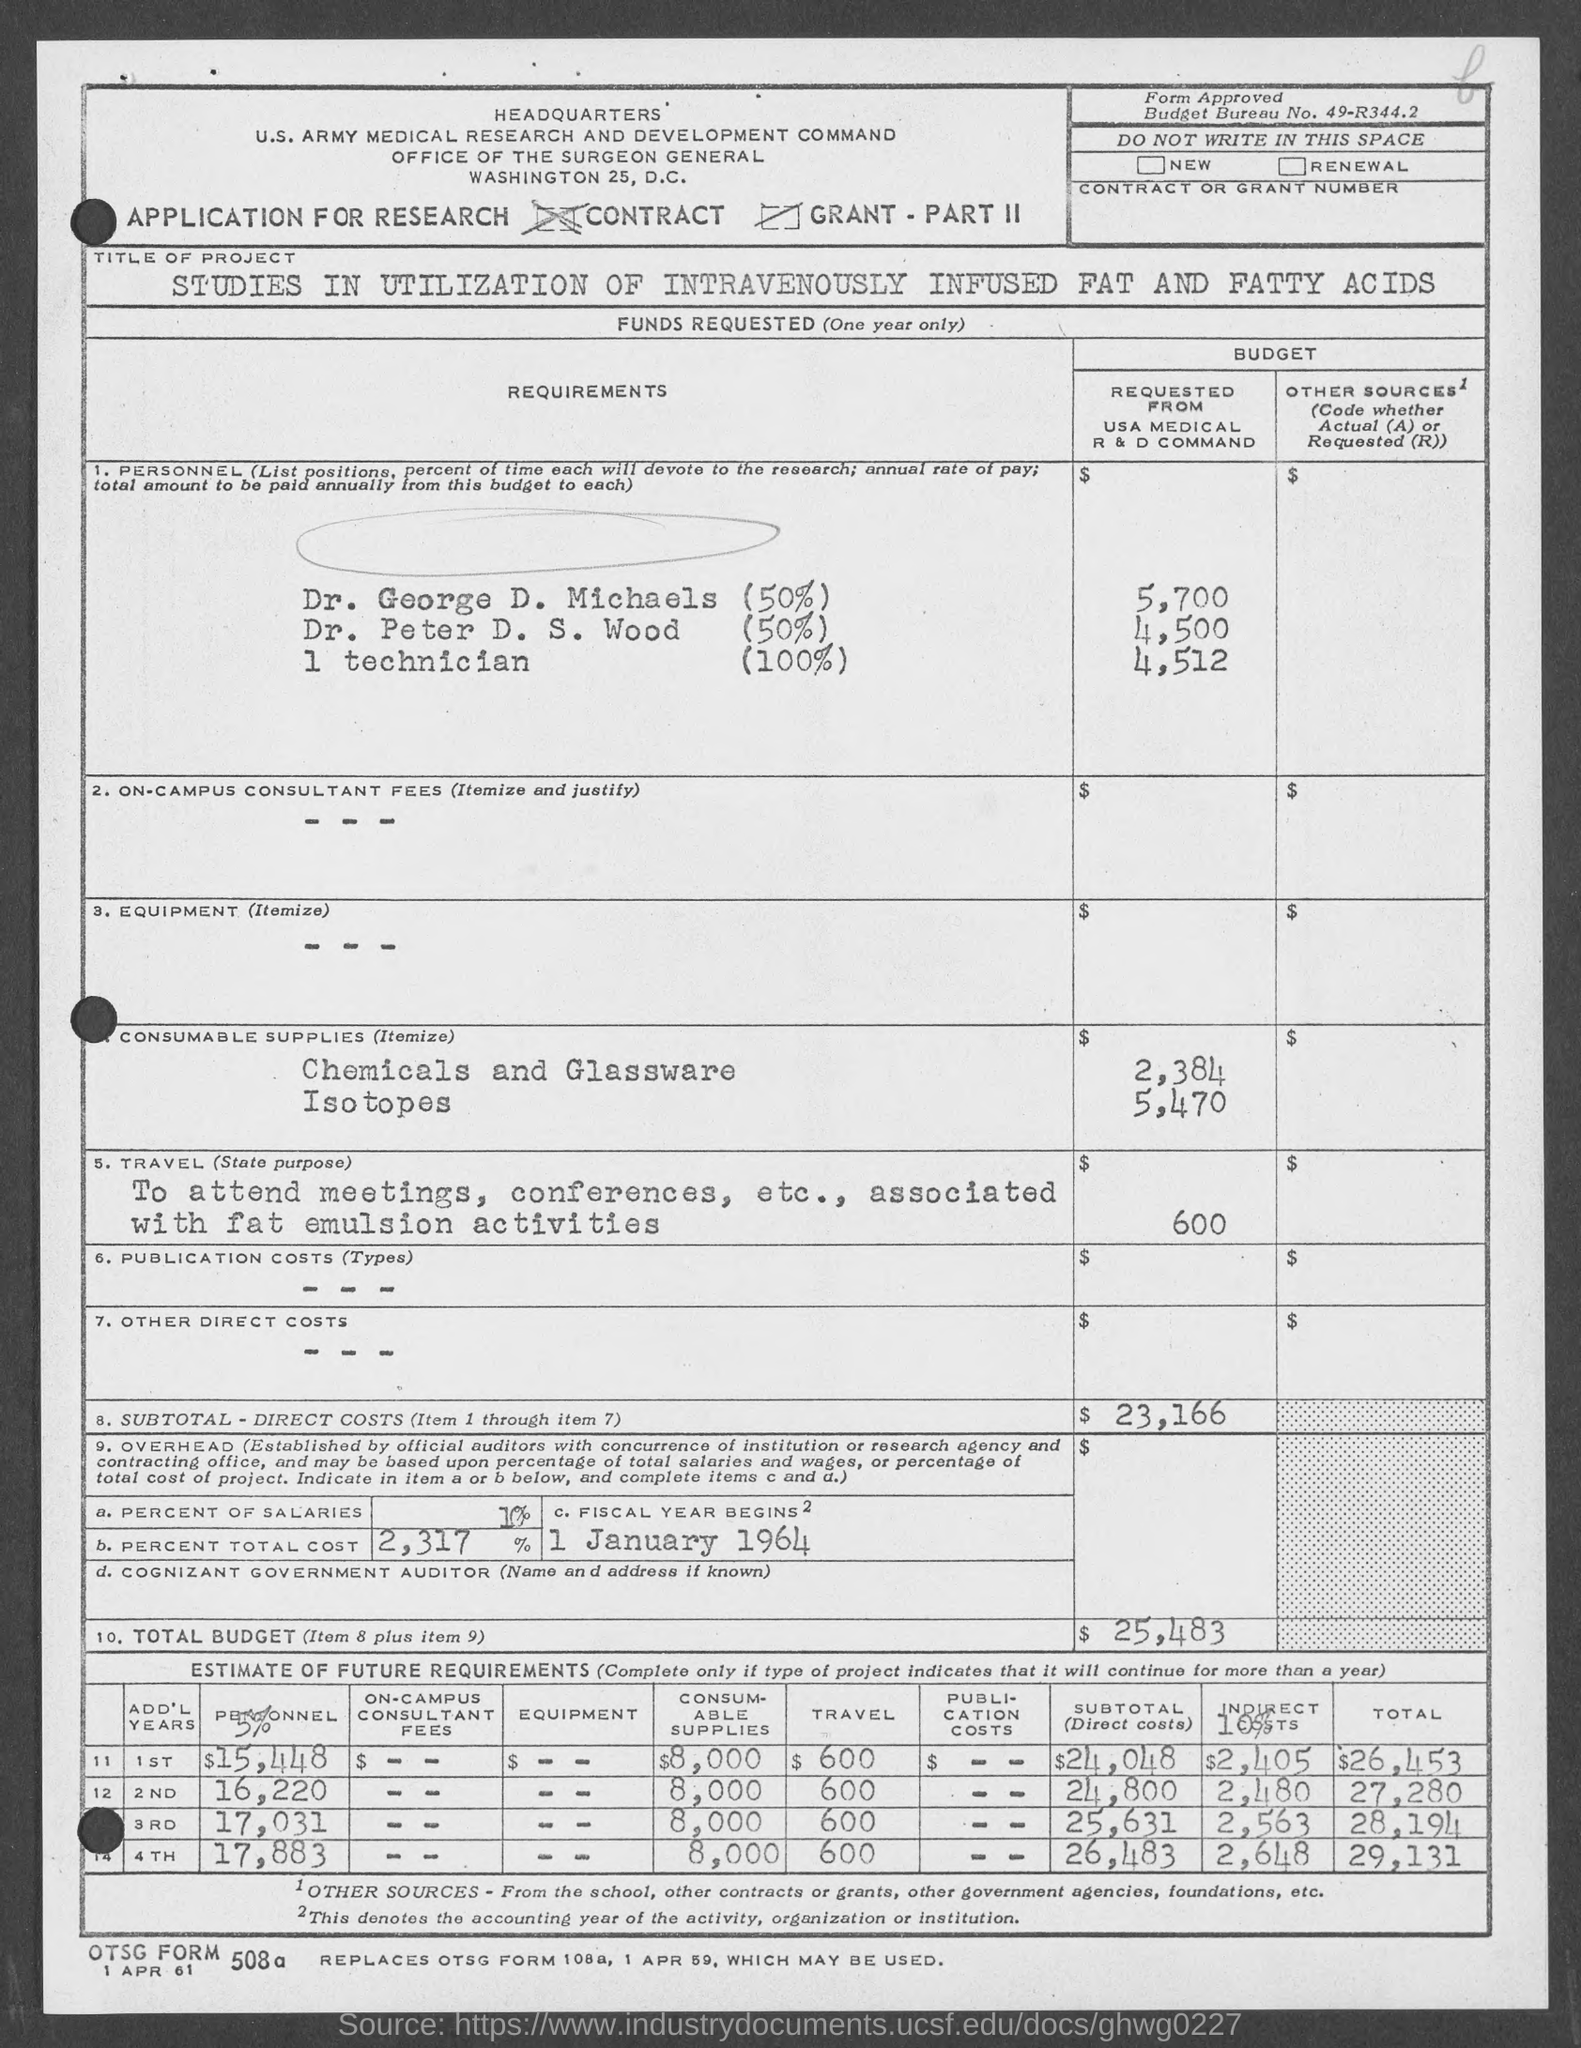Point out several critical features in this image. The fiscal year begins on January 1, 1964. The budget bureau number is 49-R344.2. 